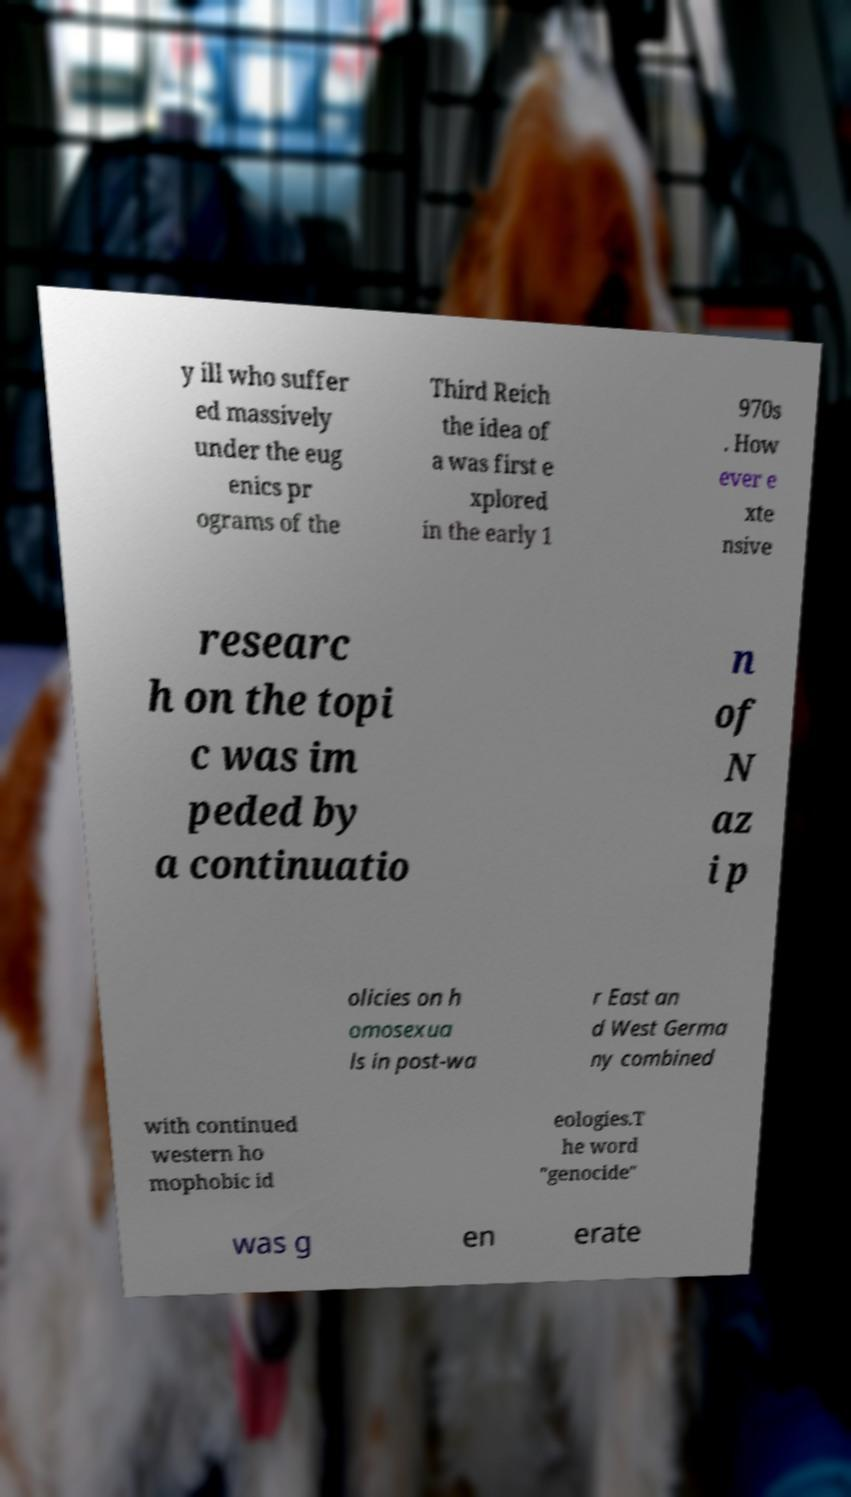Could you assist in decoding the text presented in this image and type it out clearly? y ill who suffer ed massively under the eug enics pr ograms of the Third Reich the idea of a was first e xplored in the early 1 970s . How ever e xte nsive researc h on the topi c was im peded by a continuatio n of N az i p olicies on h omosexua ls in post-wa r East an d West Germa ny combined with continued western ho mophobic id eologies.T he word "genocide" was g en erate 